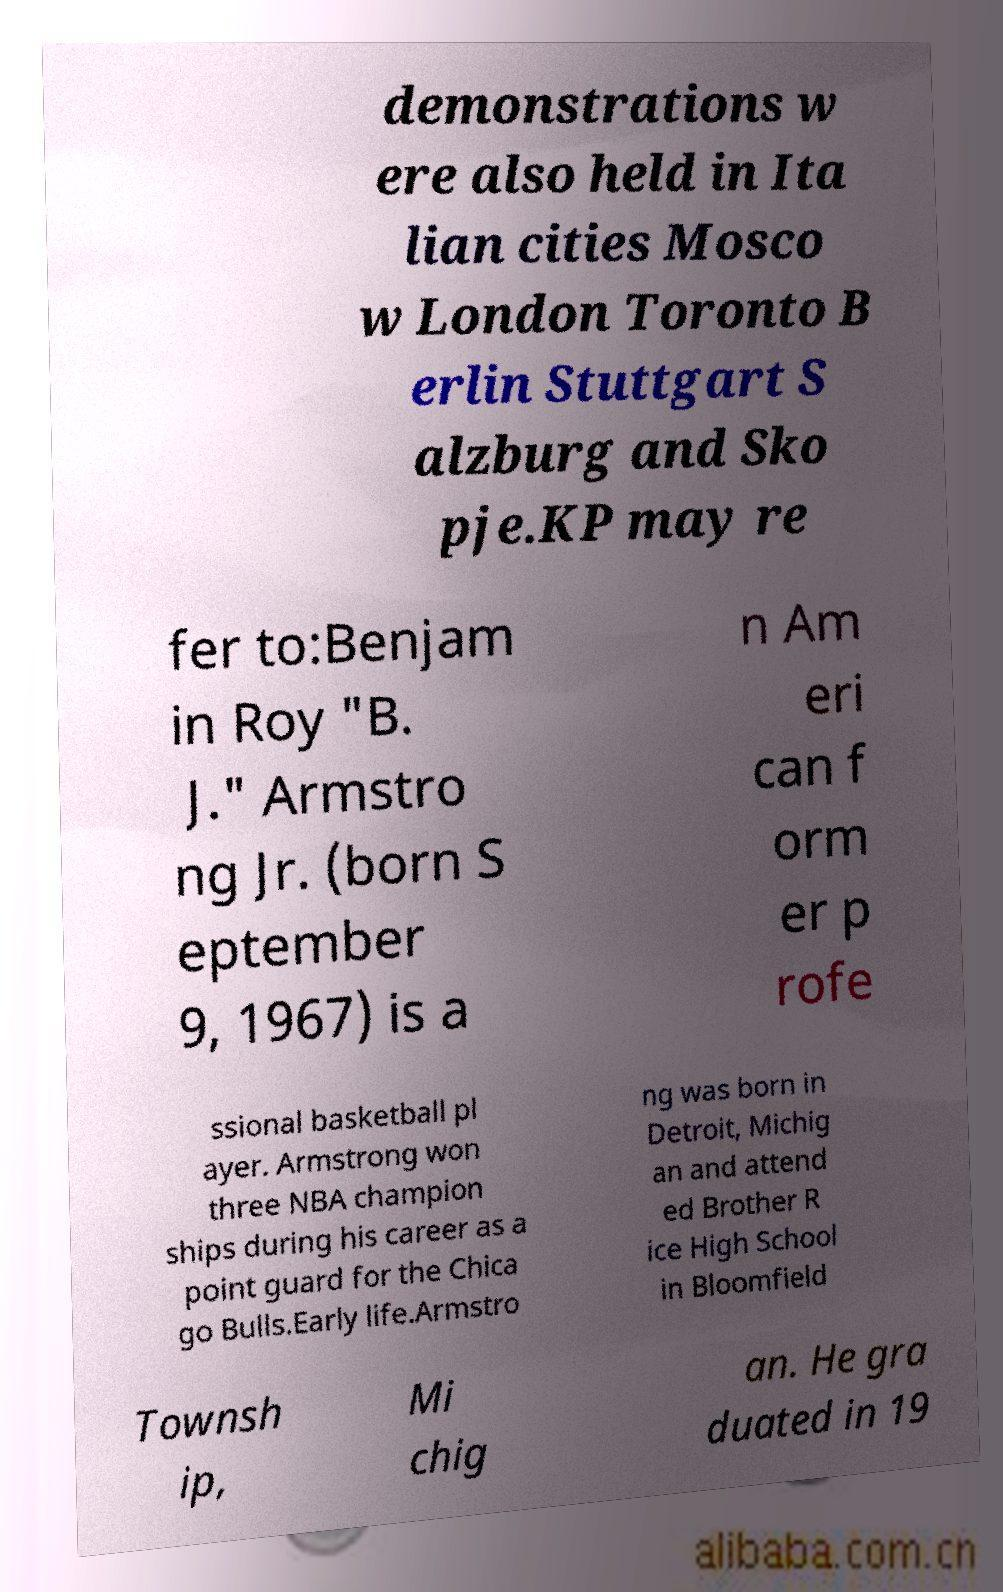What messages or text are displayed in this image? I need them in a readable, typed format. demonstrations w ere also held in Ita lian cities Mosco w London Toronto B erlin Stuttgart S alzburg and Sko pje.KP may re fer to:Benjam in Roy "B. J." Armstro ng Jr. (born S eptember 9, 1967) is a n Am eri can f orm er p rofe ssional basketball pl ayer. Armstrong won three NBA champion ships during his career as a point guard for the Chica go Bulls.Early life.Armstro ng was born in Detroit, Michig an and attend ed Brother R ice High School in Bloomfield Townsh ip, Mi chig an. He gra duated in 19 